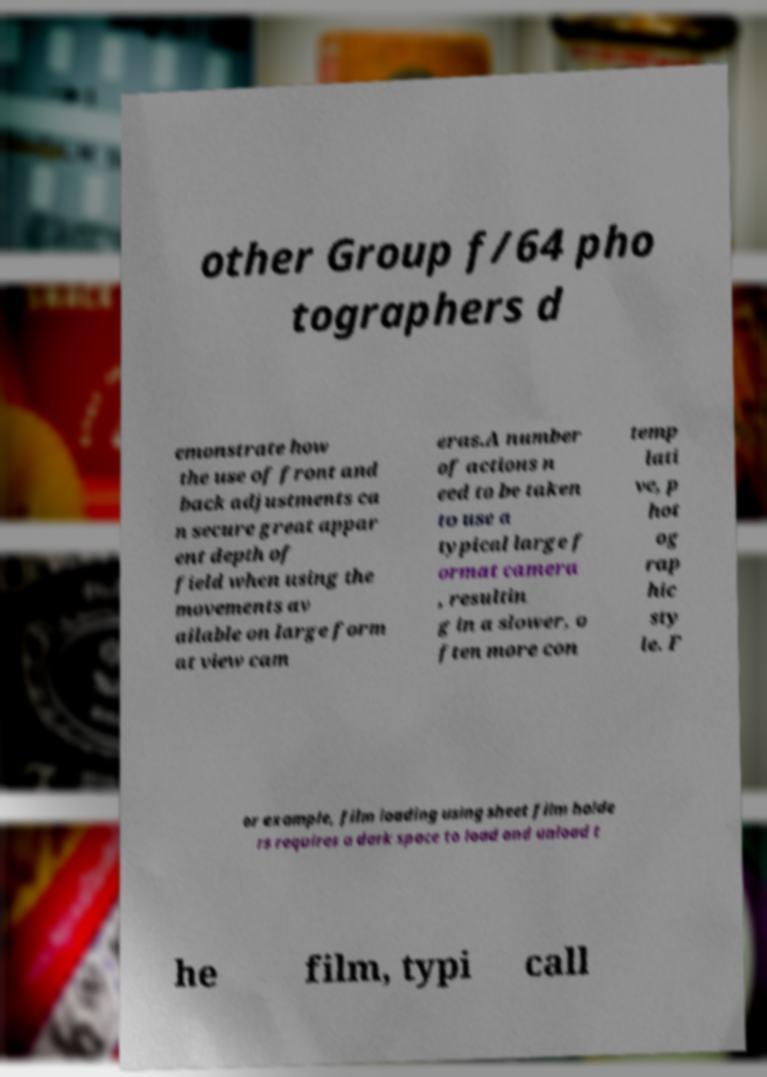Could you extract and type out the text from this image? other Group f/64 pho tographers d emonstrate how the use of front and back adjustments ca n secure great appar ent depth of field when using the movements av ailable on large form at view cam eras.A number of actions n eed to be taken to use a typical large f ormat camera , resultin g in a slower, o ften more con temp lati ve, p hot og rap hic sty le. F or example, film loading using sheet film holde rs requires a dark space to load and unload t he film, typi call 